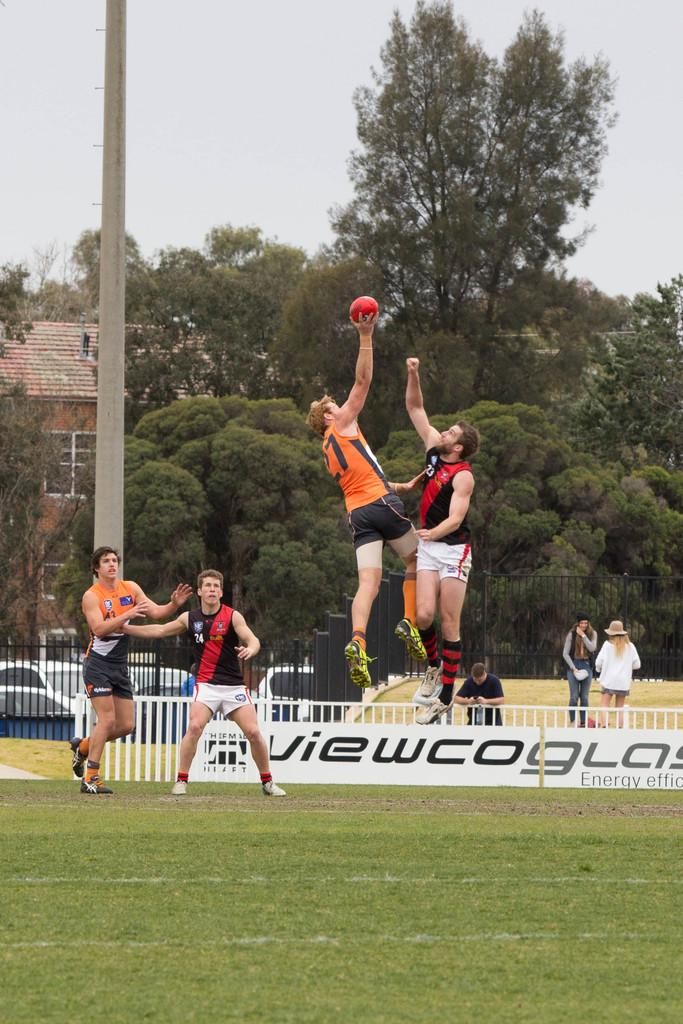<image>
Relay a brief, clear account of the picture shown. Four men playing a ball sport, on a field sponsored by viewco glass. 